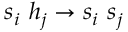<formula> <loc_0><loc_0><loc_500><loc_500>s _ { i } \ h _ { j } \to s _ { i } \ s _ { j }</formula> 